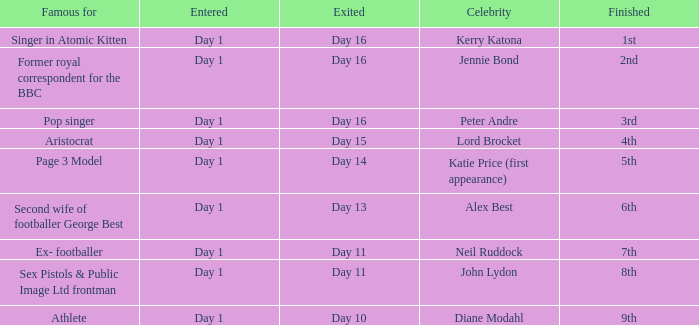Name who was famous for finished in 9th Athlete. 